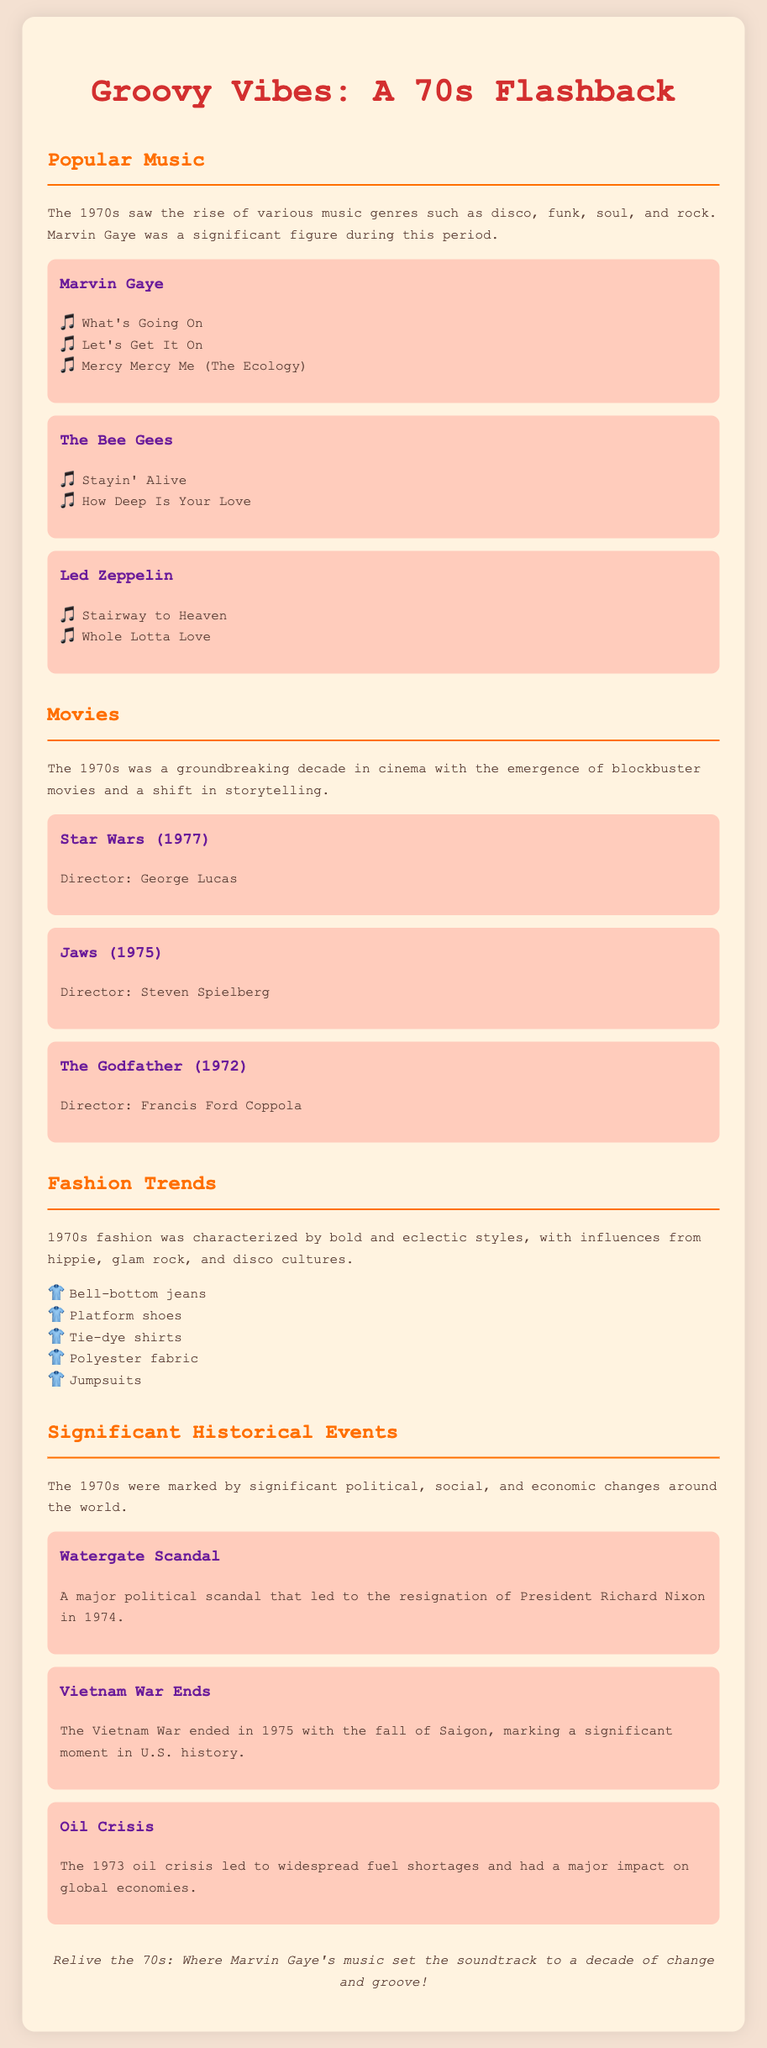What was the significant album released by Marvin Gaye in 1971? The document mentions that "What's Going On" is one of the significant works by Marvin Gaye during the 1970s.
Answer: What's Going On Who directed the movie "Jaws"? The document lists Steven Spielberg as the director of "Jaws."
Answer: Steven Spielberg What fashion item is described as a popular trend in the 1970s? The document includes "Bell-bottom jeans" as one of the popular fashion trends of the decade.
Answer: Bell-bottom jeans In what year did the Vietnam War end? The document states that the Vietnam War ended in 1975.
Answer: 1975 Which music genre rose during the 1970s? The document notes that funk is one of the music genres that saw a rise during the 1970s.
Answer: Funk What was a key political event in 1974? The Watergate Scandal led to President Richard Nixon's resignation and is highlighted as a significant political event in the document.
Answer: Watergate Scandal Name a popular disco group mentioned in the document. The document refers to The Bee Gees as a popular disco group.
Answer: The Bee Gees Which movie released in 1977 is mentioned? The document highlights "Star Wars" as a significant movie from 1977.
Answer: Star Wars 